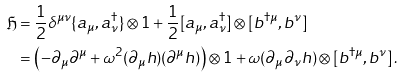Convert formula to latex. <formula><loc_0><loc_0><loc_500><loc_500>\mathfrak { H } & = \frac { 1 } { 2 } \delta ^ { \mu \nu } \{ a _ { \mu } , a _ { \nu } ^ { \dag } \} \otimes 1 + \frac { 1 } { 2 } [ a _ { \mu } , a _ { \nu } ^ { \dag } ] \otimes [ b ^ { \dag \mu } , b ^ { \nu } ] \\ & = \left ( - \partial _ { \mu } \partial ^ { \mu } + \omega ^ { 2 } ( \partial _ { \mu } h ) ( \partial ^ { \mu } h ) \right ) \otimes 1 + \omega ( \partial _ { \mu } \partial _ { \nu } h ) \otimes [ b ^ { \dag \mu } , b ^ { \nu } ] \, .</formula> 